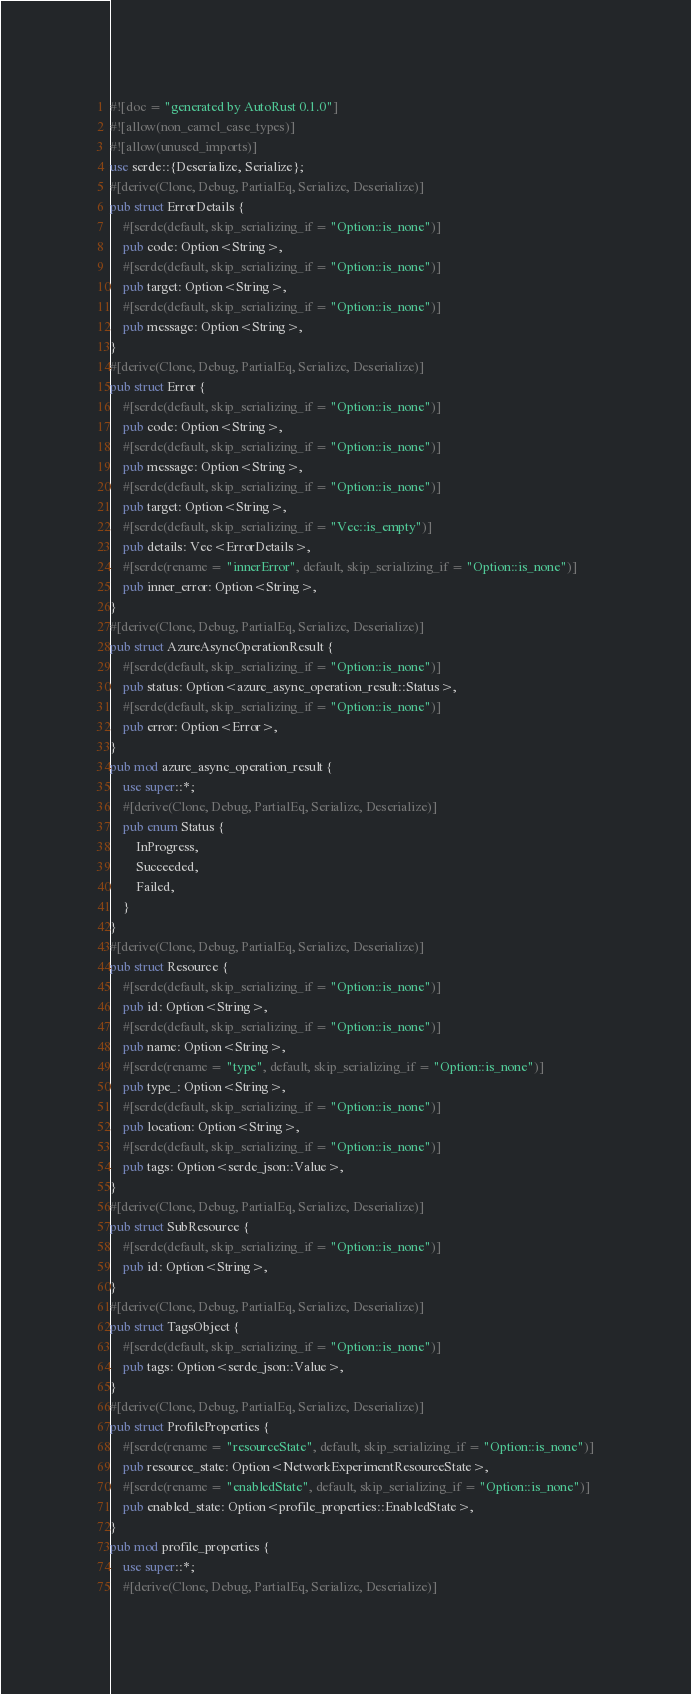<code> <loc_0><loc_0><loc_500><loc_500><_Rust_>#![doc = "generated by AutoRust 0.1.0"]
#![allow(non_camel_case_types)]
#![allow(unused_imports)]
use serde::{Deserialize, Serialize};
#[derive(Clone, Debug, PartialEq, Serialize, Deserialize)]
pub struct ErrorDetails {
    #[serde(default, skip_serializing_if = "Option::is_none")]
    pub code: Option<String>,
    #[serde(default, skip_serializing_if = "Option::is_none")]
    pub target: Option<String>,
    #[serde(default, skip_serializing_if = "Option::is_none")]
    pub message: Option<String>,
}
#[derive(Clone, Debug, PartialEq, Serialize, Deserialize)]
pub struct Error {
    #[serde(default, skip_serializing_if = "Option::is_none")]
    pub code: Option<String>,
    #[serde(default, skip_serializing_if = "Option::is_none")]
    pub message: Option<String>,
    #[serde(default, skip_serializing_if = "Option::is_none")]
    pub target: Option<String>,
    #[serde(default, skip_serializing_if = "Vec::is_empty")]
    pub details: Vec<ErrorDetails>,
    #[serde(rename = "innerError", default, skip_serializing_if = "Option::is_none")]
    pub inner_error: Option<String>,
}
#[derive(Clone, Debug, PartialEq, Serialize, Deserialize)]
pub struct AzureAsyncOperationResult {
    #[serde(default, skip_serializing_if = "Option::is_none")]
    pub status: Option<azure_async_operation_result::Status>,
    #[serde(default, skip_serializing_if = "Option::is_none")]
    pub error: Option<Error>,
}
pub mod azure_async_operation_result {
    use super::*;
    #[derive(Clone, Debug, PartialEq, Serialize, Deserialize)]
    pub enum Status {
        InProgress,
        Succeeded,
        Failed,
    }
}
#[derive(Clone, Debug, PartialEq, Serialize, Deserialize)]
pub struct Resource {
    #[serde(default, skip_serializing_if = "Option::is_none")]
    pub id: Option<String>,
    #[serde(default, skip_serializing_if = "Option::is_none")]
    pub name: Option<String>,
    #[serde(rename = "type", default, skip_serializing_if = "Option::is_none")]
    pub type_: Option<String>,
    #[serde(default, skip_serializing_if = "Option::is_none")]
    pub location: Option<String>,
    #[serde(default, skip_serializing_if = "Option::is_none")]
    pub tags: Option<serde_json::Value>,
}
#[derive(Clone, Debug, PartialEq, Serialize, Deserialize)]
pub struct SubResource {
    #[serde(default, skip_serializing_if = "Option::is_none")]
    pub id: Option<String>,
}
#[derive(Clone, Debug, PartialEq, Serialize, Deserialize)]
pub struct TagsObject {
    #[serde(default, skip_serializing_if = "Option::is_none")]
    pub tags: Option<serde_json::Value>,
}
#[derive(Clone, Debug, PartialEq, Serialize, Deserialize)]
pub struct ProfileProperties {
    #[serde(rename = "resourceState", default, skip_serializing_if = "Option::is_none")]
    pub resource_state: Option<NetworkExperimentResourceState>,
    #[serde(rename = "enabledState", default, skip_serializing_if = "Option::is_none")]
    pub enabled_state: Option<profile_properties::EnabledState>,
}
pub mod profile_properties {
    use super::*;
    #[derive(Clone, Debug, PartialEq, Serialize, Deserialize)]</code> 